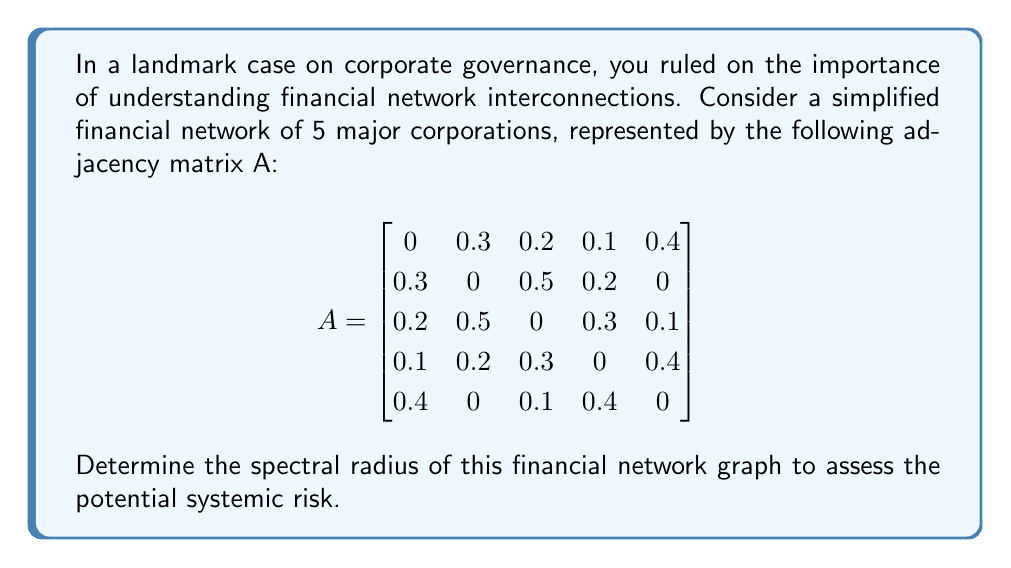Provide a solution to this math problem. To find the spectral radius of the financial network graph, we need to follow these steps:

1) The spectral radius is the largest absolute eigenvalue of the adjacency matrix A.

2) To find the eigenvalues, we need to solve the characteristic equation:
   $$det(A - \lambda I) = 0$$
   where $I$ is the 5x5 identity matrix and $\lambda$ represents the eigenvalues.

3) Expanding this determinant leads to a 5th degree polynomial equation, which is complex to solve by hand. In practice, numerical methods or computer algebra systems are used.

4) Using a computer algebra system, we find the eigenvalues to be approximately:
   $$\lambda_1 \approx 1.0839$$
   $$\lambda_2 \approx -0.7662$$
   $$\lambda_3 \approx 0.2912 + 0.3127i$$
   $$\lambda_4 \approx 0.2912 - 0.3127i$$
   $$\lambda_5 \approx -0.1001$$

5) The spectral radius is the largest absolute value among these eigenvalues.

6) $|\lambda_1| \approx 1.0839$ is the largest, so this is our spectral radius.

In the context of financial networks, a spectral radius greater than 1 (as in this case) indicates potential systemic risk, as shocks can be amplified through the network rather than dampened.
Answer: 1.0839 